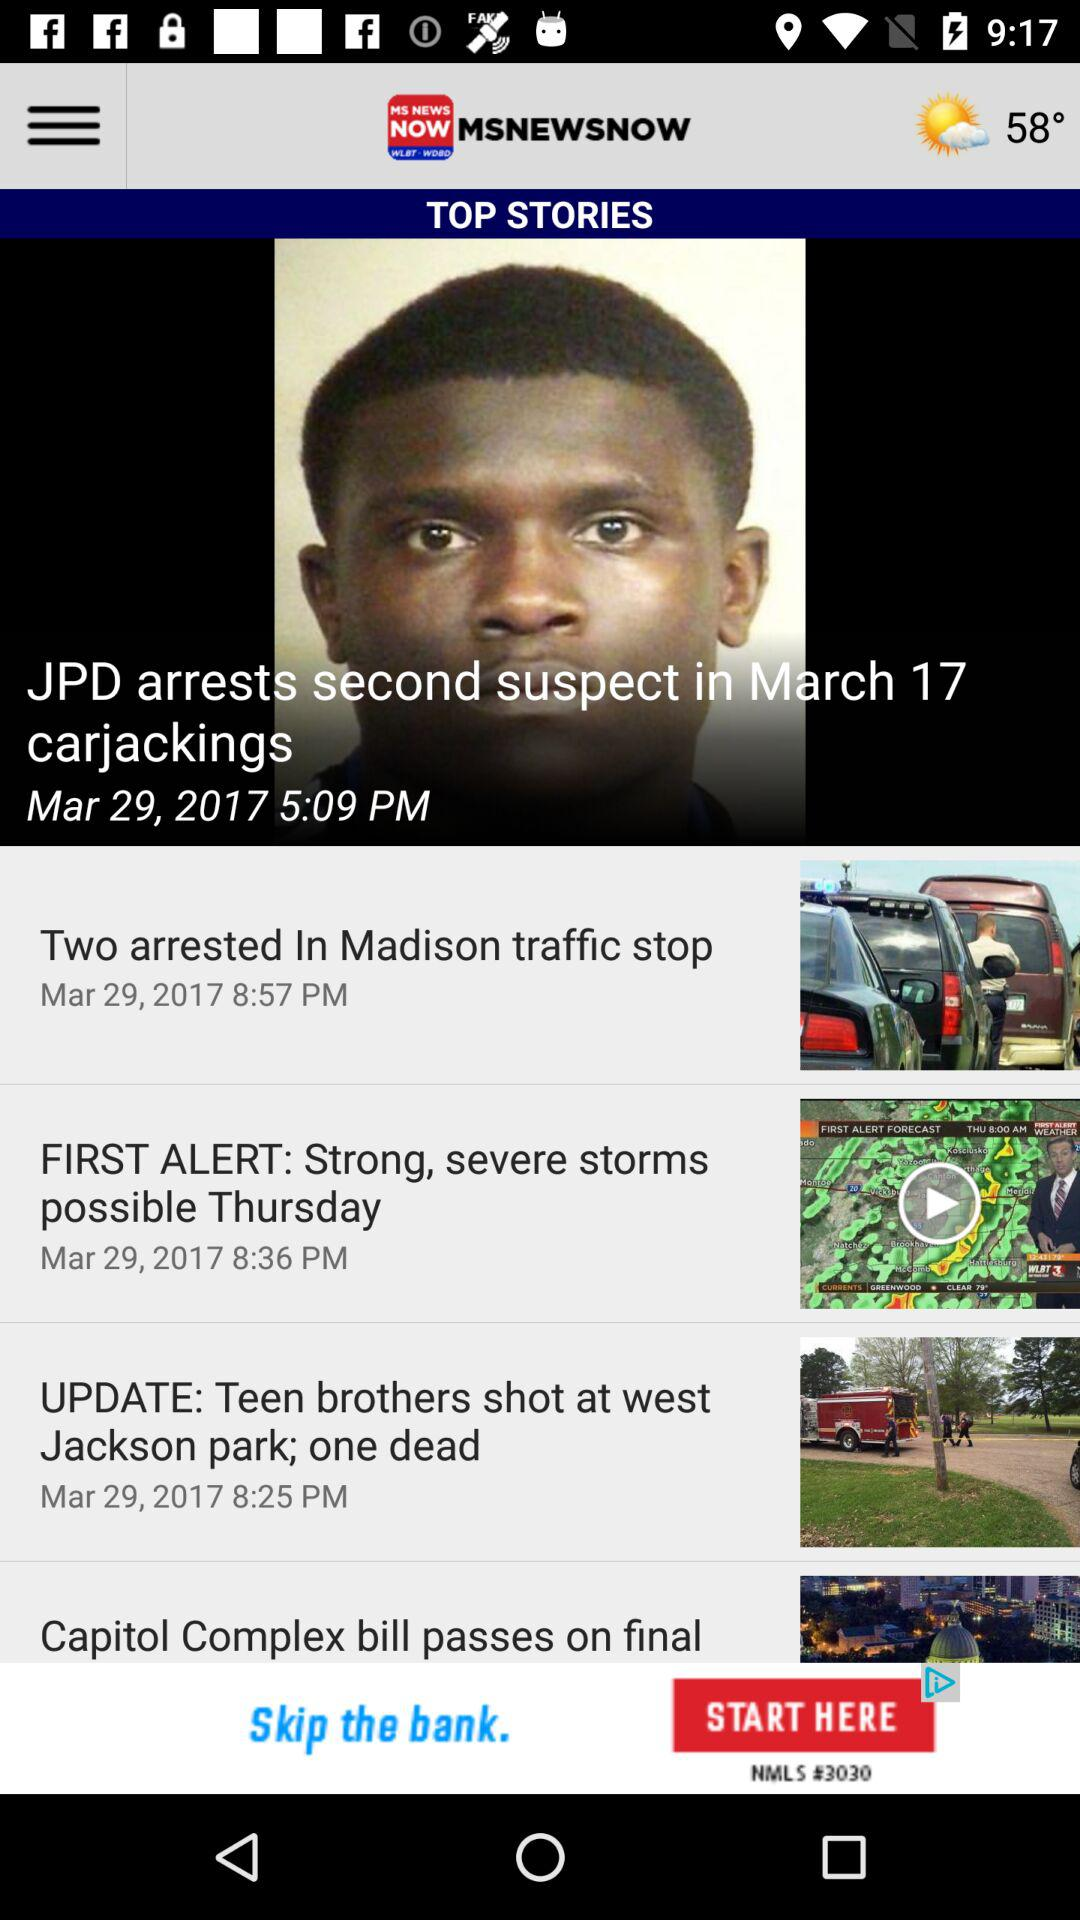When was the "FIRST ALERT" news uploaded? The news was uploaded on March 29, 2017 at 8:36 PM. 